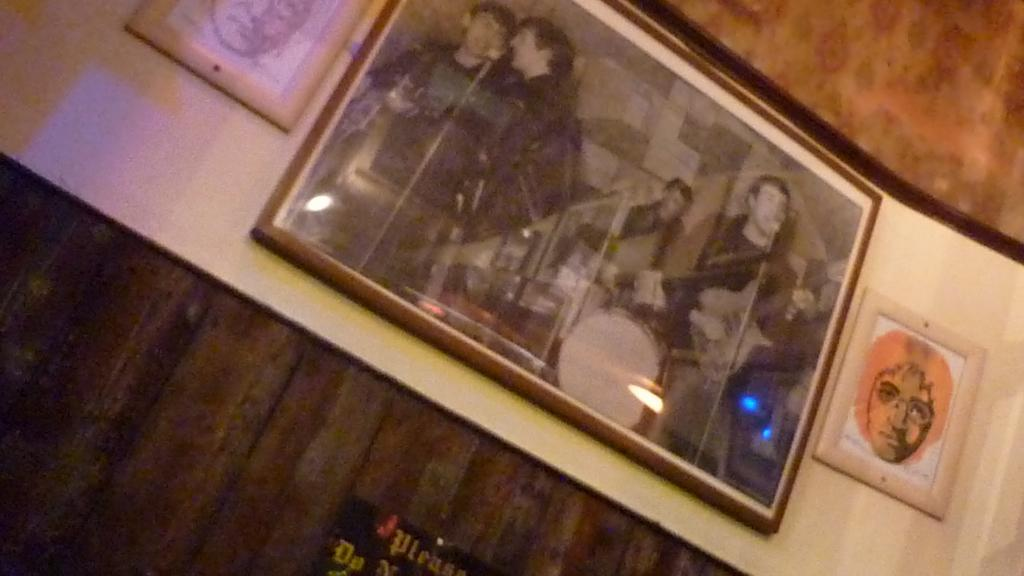What is attached to the wall in the image? There are photo frames attached to a wall in the image. What can be seen in the photo frames? The photo frames contain pictures of people and other things. Are there any plants growing in the photo frames in the image? No, there are no plants growing in the photo frames in the image. Can you purchase a ticket to enter the photo frames in the image? No, the photo frames are not a physical location where you can purchase a ticket to enter. 